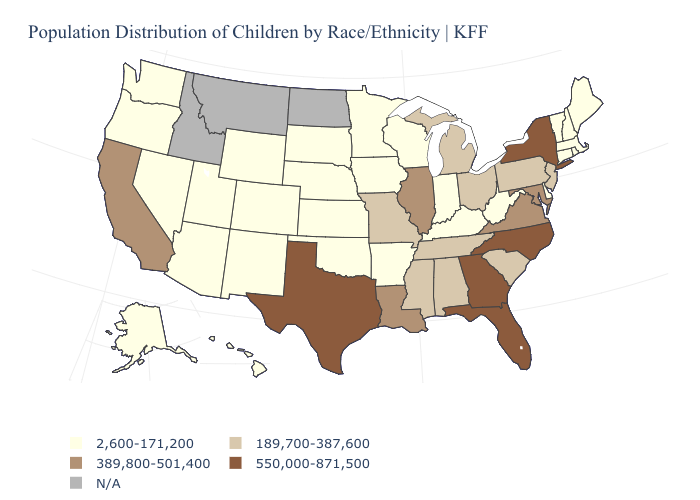Does Arkansas have the highest value in the USA?
Give a very brief answer. No. Name the states that have a value in the range 2,600-171,200?
Quick response, please. Alaska, Arizona, Arkansas, Colorado, Connecticut, Delaware, Hawaii, Indiana, Iowa, Kansas, Kentucky, Maine, Massachusetts, Minnesota, Nebraska, Nevada, New Hampshire, New Mexico, Oklahoma, Oregon, Rhode Island, South Dakota, Utah, Vermont, Washington, West Virginia, Wisconsin, Wyoming. What is the value of Colorado?
Quick response, please. 2,600-171,200. What is the lowest value in states that border Rhode Island?
Concise answer only. 2,600-171,200. Which states have the highest value in the USA?
Answer briefly. Florida, Georgia, New York, North Carolina, Texas. Does New Jersey have the lowest value in the Northeast?
Concise answer only. No. What is the lowest value in the USA?
Keep it brief. 2,600-171,200. What is the highest value in states that border Maine?
Be succinct. 2,600-171,200. What is the value of Arkansas?
Concise answer only. 2,600-171,200. Name the states that have a value in the range 189,700-387,600?
Quick response, please. Alabama, Michigan, Mississippi, Missouri, New Jersey, Ohio, Pennsylvania, South Carolina, Tennessee. Name the states that have a value in the range 189,700-387,600?
Be succinct. Alabama, Michigan, Mississippi, Missouri, New Jersey, Ohio, Pennsylvania, South Carolina, Tennessee. What is the highest value in the USA?
Be succinct. 550,000-871,500. Which states hav the highest value in the South?
Give a very brief answer. Florida, Georgia, North Carolina, Texas. 